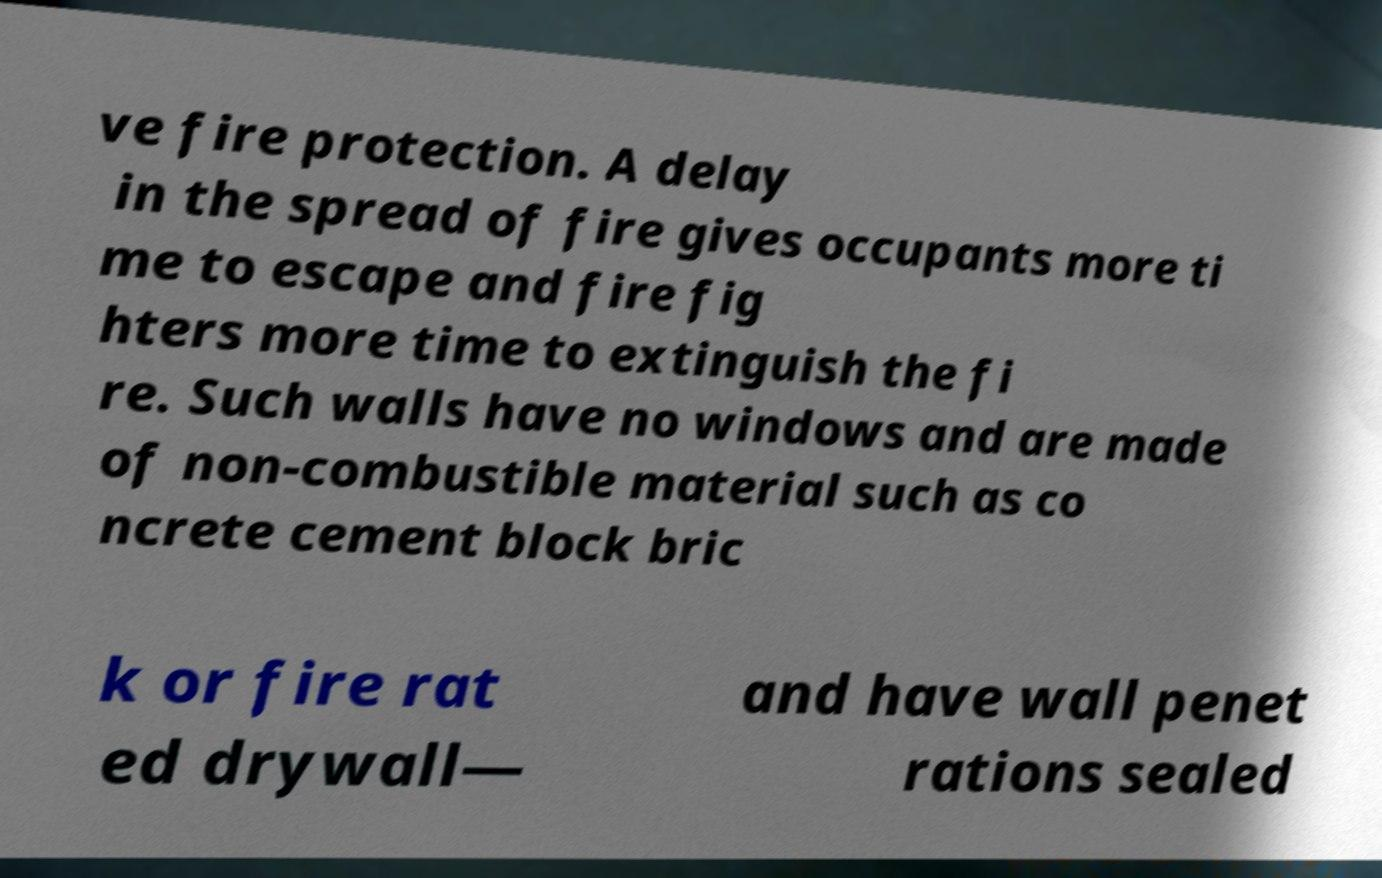Can you read and provide the text displayed in the image?This photo seems to have some interesting text. Can you extract and type it out for me? ve fire protection. A delay in the spread of fire gives occupants more ti me to escape and fire fig hters more time to extinguish the fi re. Such walls have no windows and are made of non-combustible material such as co ncrete cement block bric k or fire rat ed drywall— and have wall penet rations sealed 